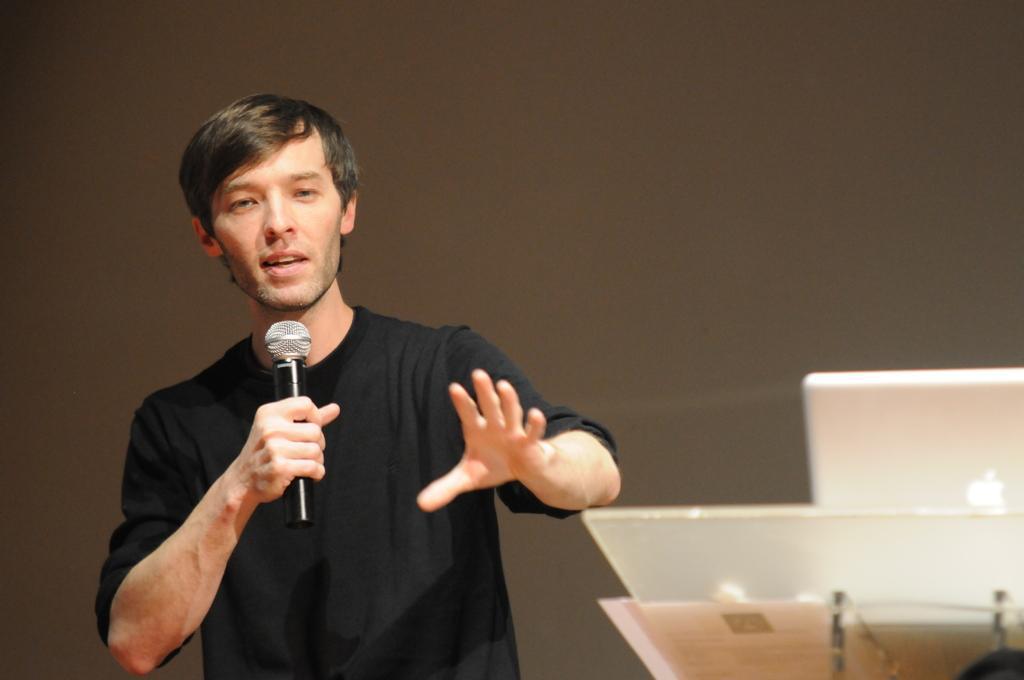Could you give a brief overview of what you see in this image? In this picture we can see a man wearing a black shirt and talking something in a mike. At the right side of the picture we can see a laptop. This is a podium. 